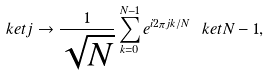<formula> <loc_0><loc_0><loc_500><loc_500>\ k e t { j } \rightarrow \frac { 1 } { \sqrt { N } } \sum _ { k = 0 } ^ { N - 1 } e ^ { i 2 \pi j k / N } \ k e t { N - 1 } ,</formula> 